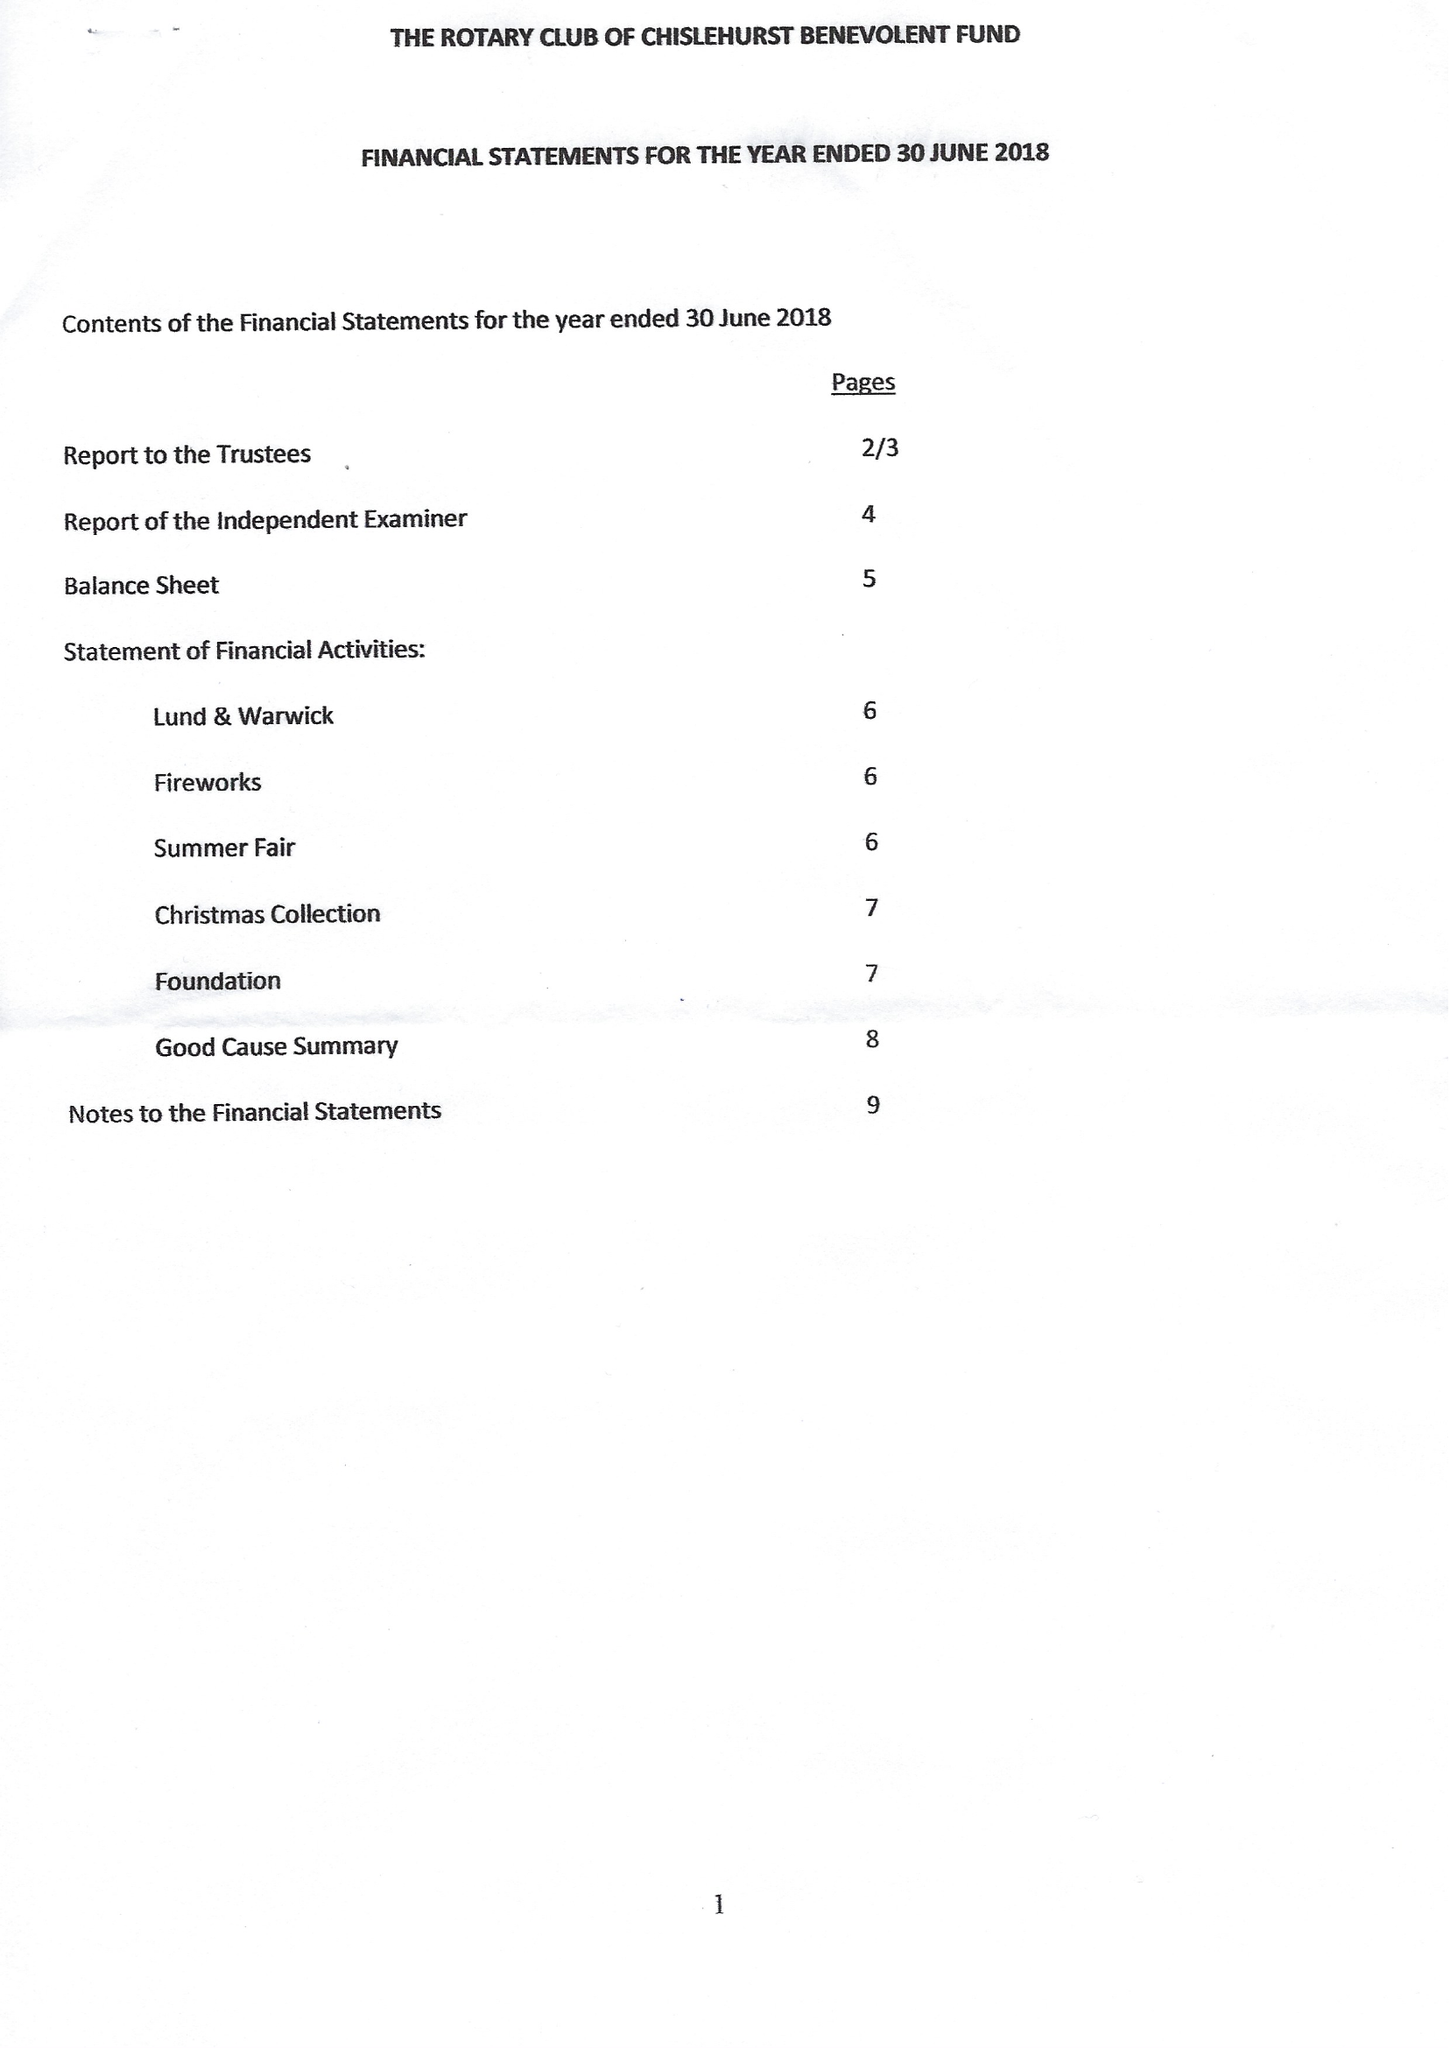What is the value for the charity_name?
Answer the question using a single word or phrase. The Rotary Club Of Chislehurst Benevolent Fund 